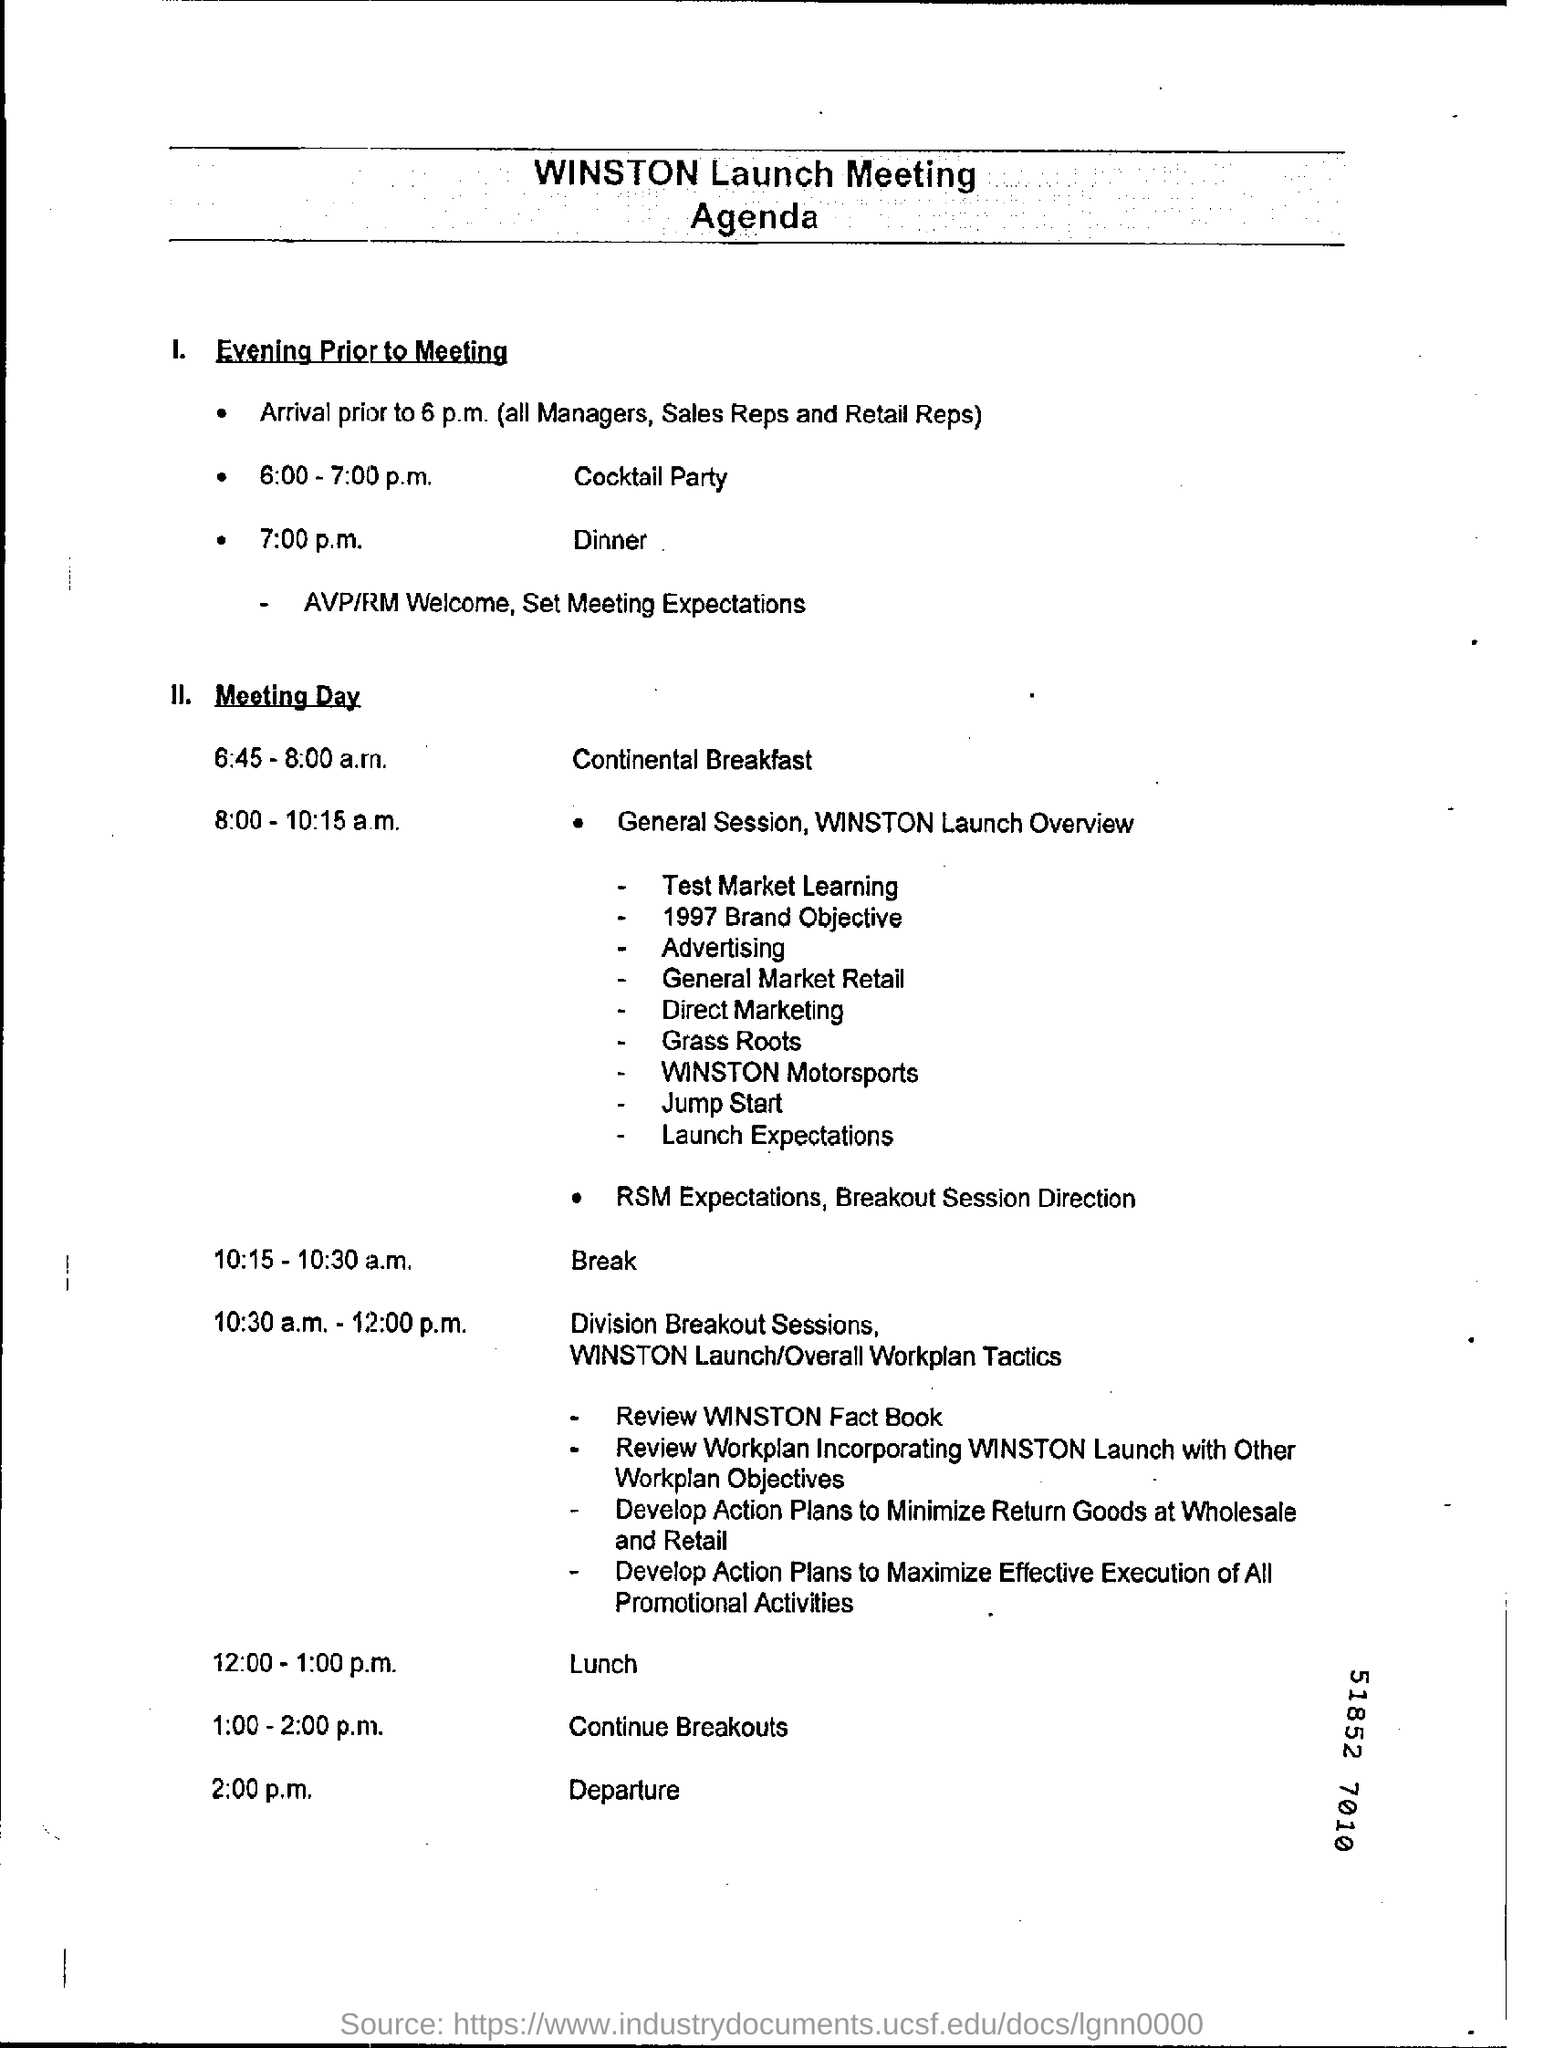What is the Agenda about?
Make the answer very short. WINSTON Launch Meeting. What is scheduled between 6:00 - 7:00 p.m. on the previous day of the meeting?
Your response must be concise. Cocktail Party. What is scheduled at 8:00 - 10:15 a.m.?
Make the answer very short. General Session, Winston Launch Overview. When is the departure?
Your answer should be very brief. 2:00 p.m. At what time is the dinner on the day prior to the meeting?
Give a very brief answer. 7:00 pm. 